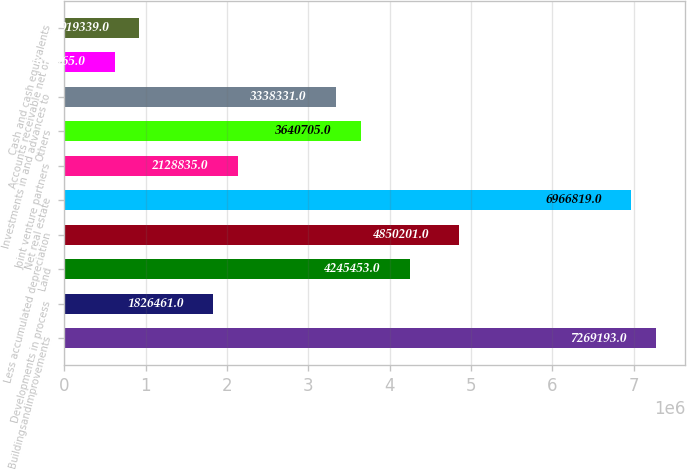<chart> <loc_0><loc_0><loc_500><loc_500><bar_chart><fcel>Buildingsandimprovements<fcel>Developments in process<fcel>Land<fcel>Less accumulated depreciation<fcel>Net real estate<fcel>Joint venture partners<fcel>Others<fcel>Investments in and advances to<fcel>Accounts receivable net of<fcel>Cash and cash equivalents<nl><fcel>7.26919e+06<fcel>1.82646e+06<fcel>4.24545e+06<fcel>4.8502e+06<fcel>6.96682e+06<fcel>2.12884e+06<fcel>3.6407e+06<fcel>3.33833e+06<fcel>616965<fcel>919339<nl></chart> 